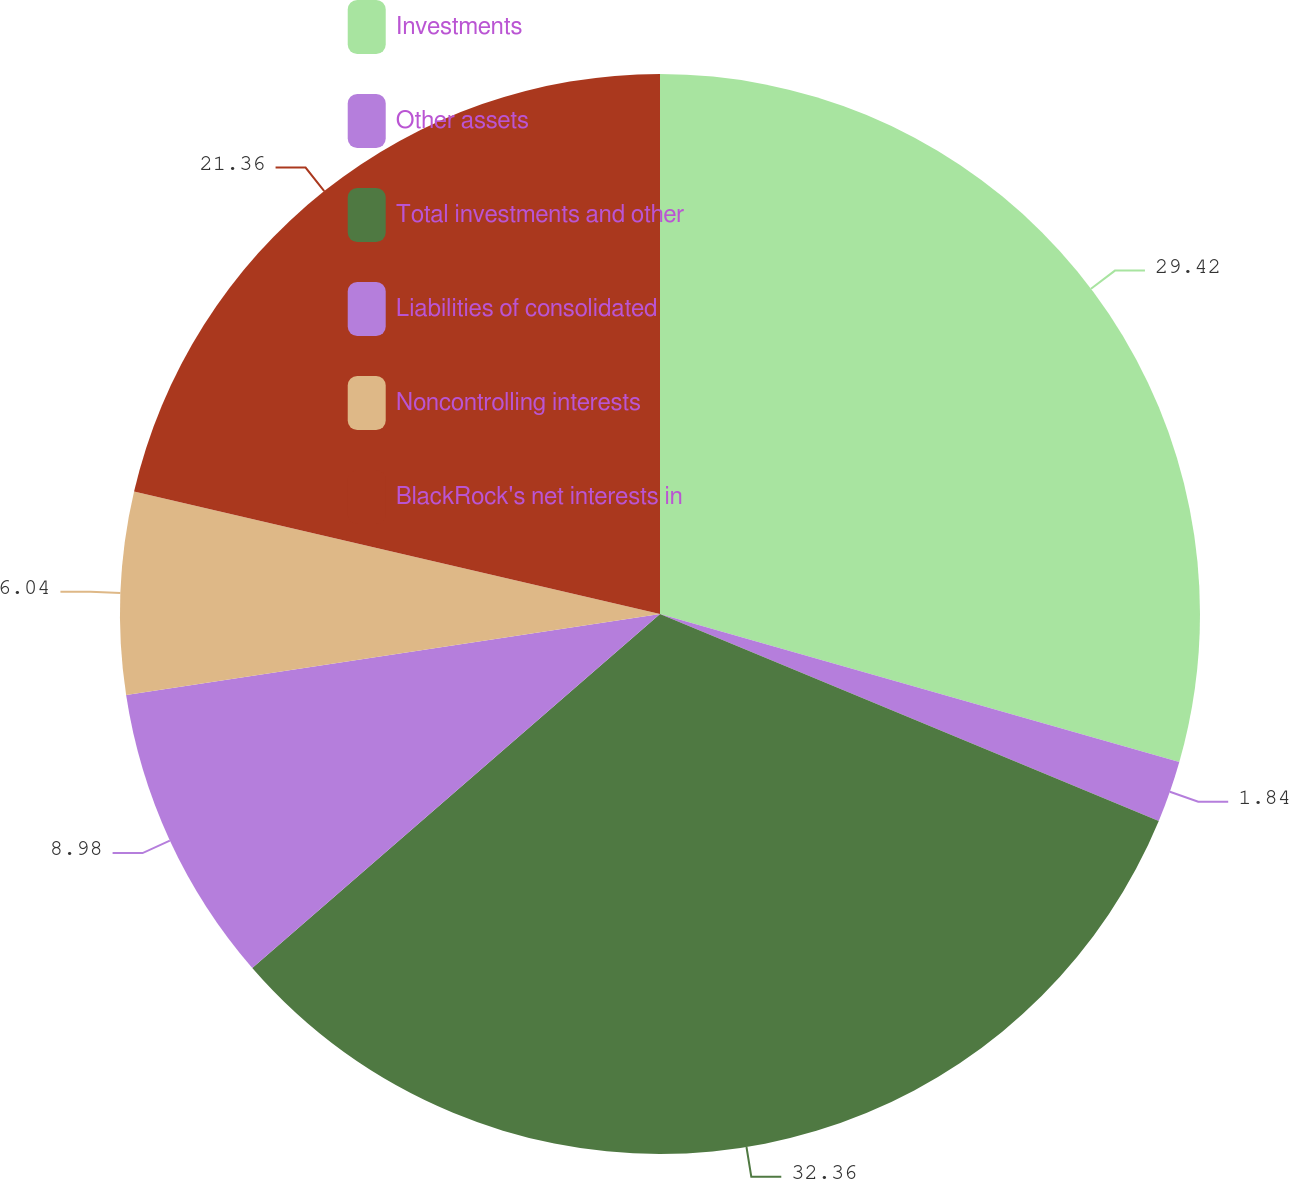Convert chart to OTSL. <chart><loc_0><loc_0><loc_500><loc_500><pie_chart><fcel>Investments<fcel>Other assets<fcel>Total investments and other<fcel>Liabilities of consolidated<fcel>Noncontrolling interests<fcel>BlackRock's net interests in<nl><fcel>29.42%<fcel>1.84%<fcel>32.36%<fcel>8.98%<fcel>6.04%<fcel>21.36%<nl></chart> 